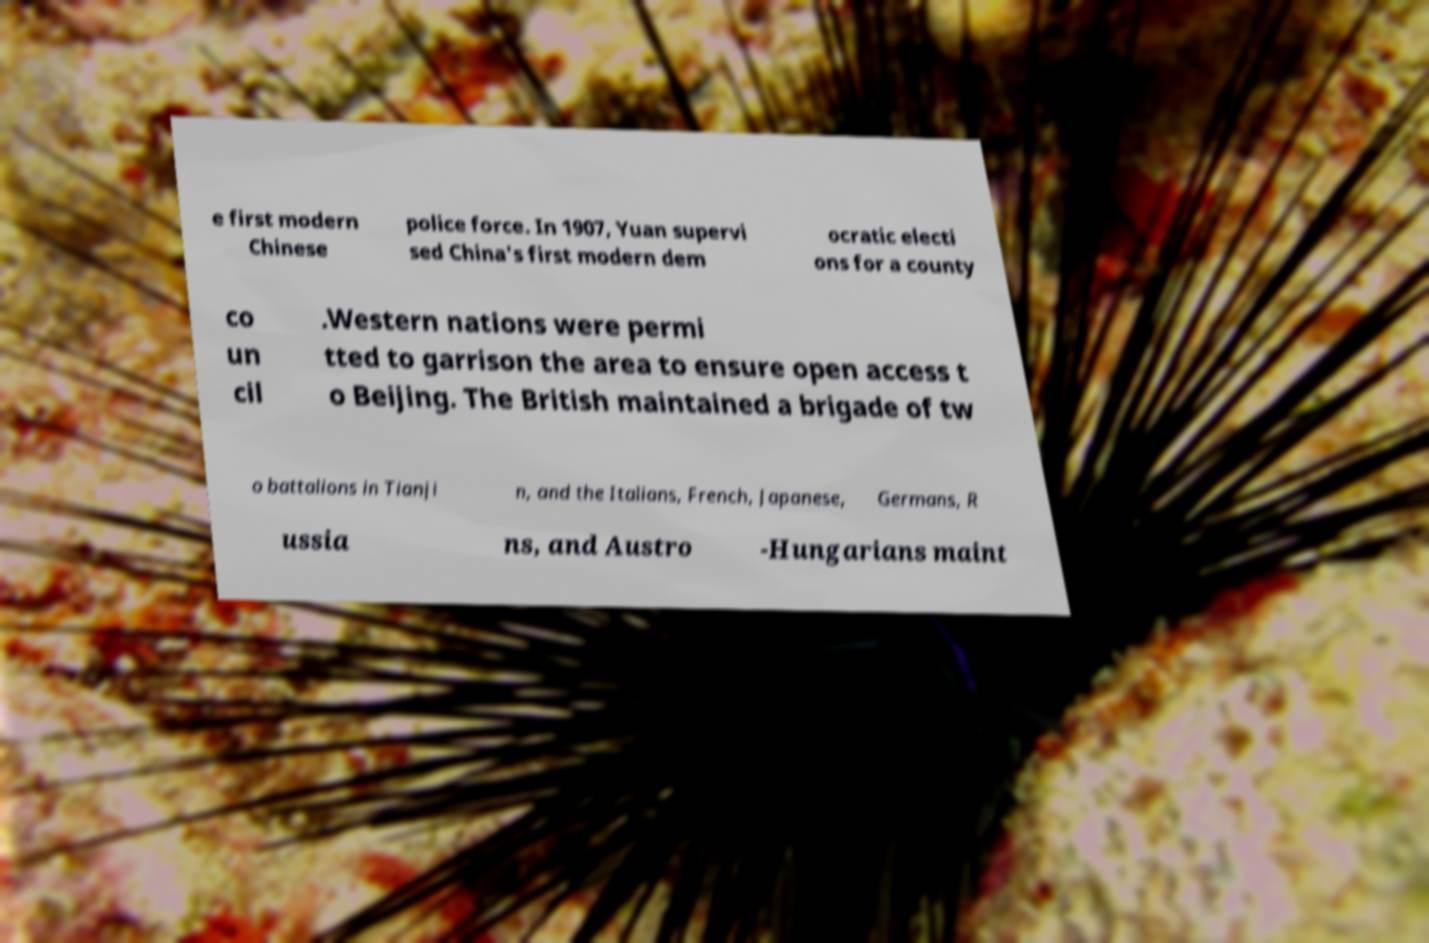What messages or text are displayed in this image? I need them in a readable, typed format. e first modern Chinese police force. In 1907, Yuan supervi sed China's first modern dem ocratic electi ons for a county co un cil .Western nations were permi tted to garrison the area to ensure open access t o Beijing. The British maintained a brigade of tw o battalions in Tianji n, and the Italians, French, Japanese, Germans, R ussia ns, and Austro -Hungarians maint 